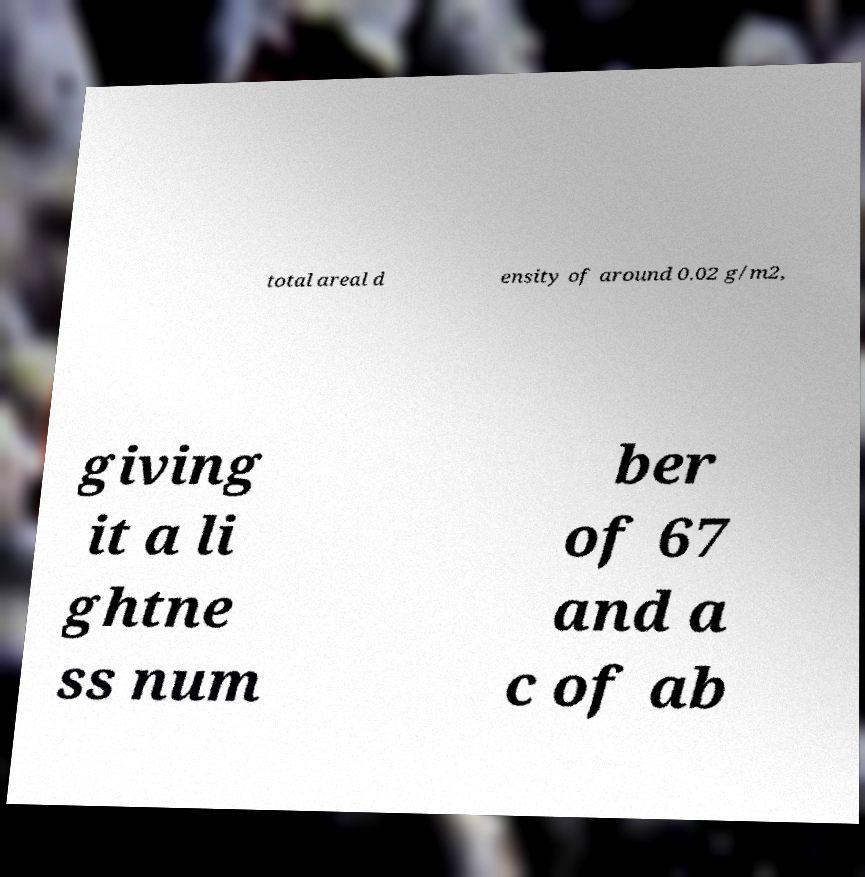Could you extract and type out the text from this image? total areal d ensity of around 0.02 g/m2, giving it a li ghtne ss num ber of 67 and a c of ab 